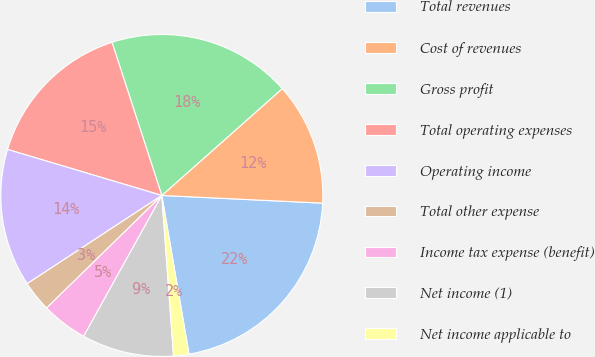Convert chart to OTSL. <chart><loc_0><loc_0><loc_500><loc_500><pie_chart><fcel>Total revenues<fcel>Cost of revenues<fcel>Gross profit<fcel>Total operating expenses<fcel>Operating income<fcel>Total other expense<fcel>Income tax expense (benefit)<fcel>Net income (1)<fcel>Net income applicable to<nl><fcel>21.54%<fcel>12.31%<fcel>18.46%<fcel>15.38%<fcel>13.85%<fcel>3.08%<fcel>4.62%<fcel>9.23%<fcel>1.54%<nl></chart> 